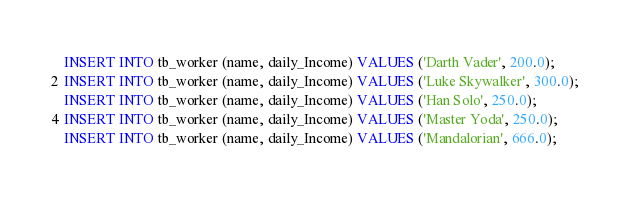<code> <loc_0><loc_0><loc_500><loc_500><_SQL_>INSERT INTO tb_worker (name, daily_Income) VALUES ('Darth Vader', 200.0);
INSERT INTO tb_worker (name, daily_Income) VALUES ('Luke Skywalker', 300.0);
INSERT INTO tb_worker (name, daily_Income) VALUES ('Han Solo', 250.0);
INSERT INTO tb_worker (name, daily_Income) VALUES ('Master Yoda', 250.0);
INSERT INTO tb_worker (name, daily_Income) VALUES ('Mandalorian', 666.0);</code> 